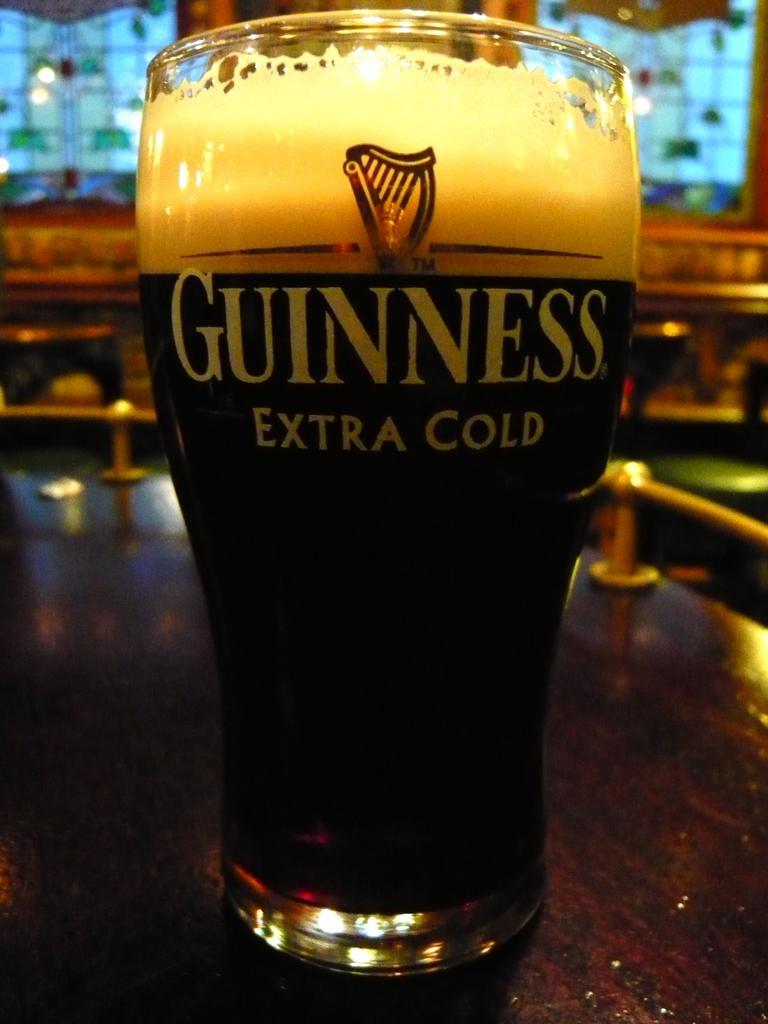Can you describe this image briefly? There is a glass with some liquid inside. On the glass something is written and it is on a table. In the background it is blurred. 